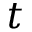Convert formula to latex. <formula><loc_0><loc_0><loc_500><loc_500>t</formula> 